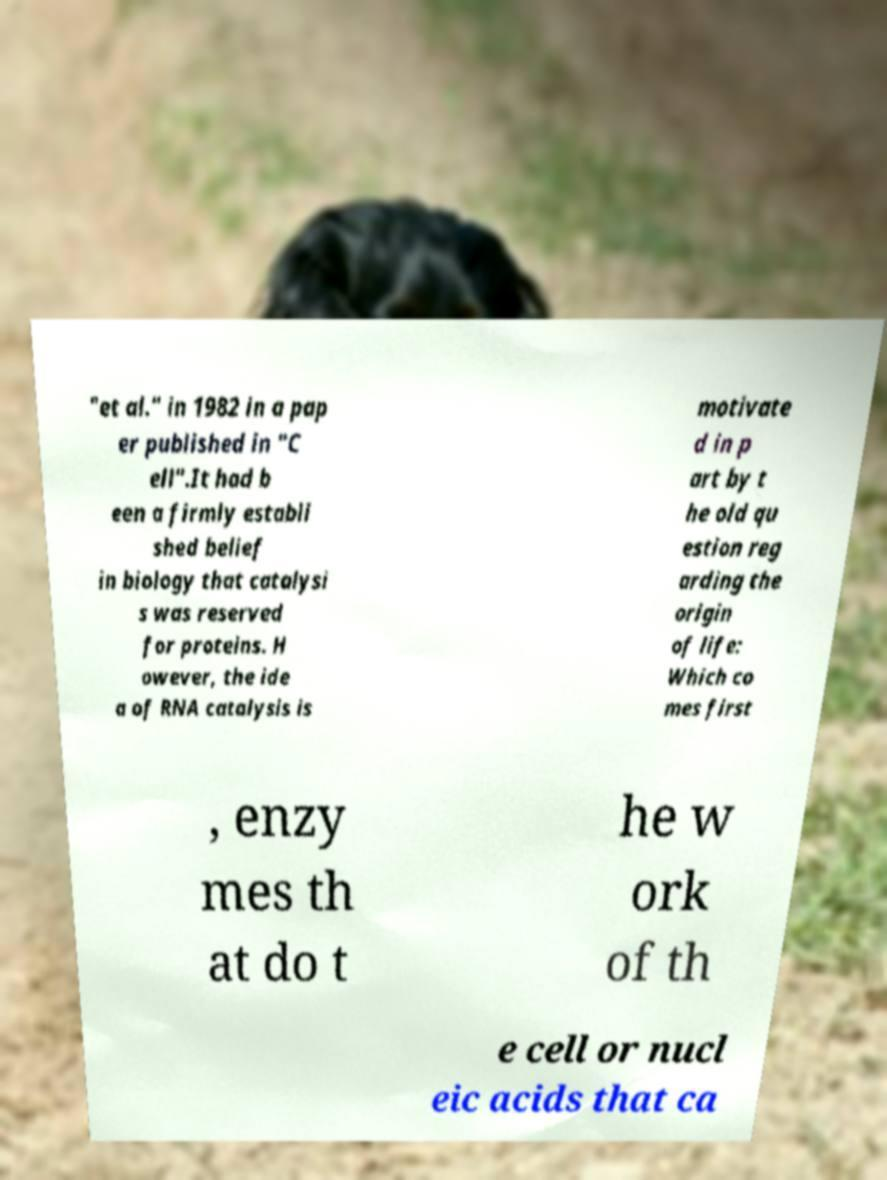Please identify and transcribe the text found in this image. "et al." in 1982 in a pap er published in "C ell".It had b een a firmly establi shed belief in biology that catalysi s was reserved for proteins. H owever, the ide a of RNA catalysis is motivate d in p art by t he old qu estion reg arding the origin of life: Which co mes first , enzy mes th at do t he w ork of th e cell or nucl eic acids that ca 